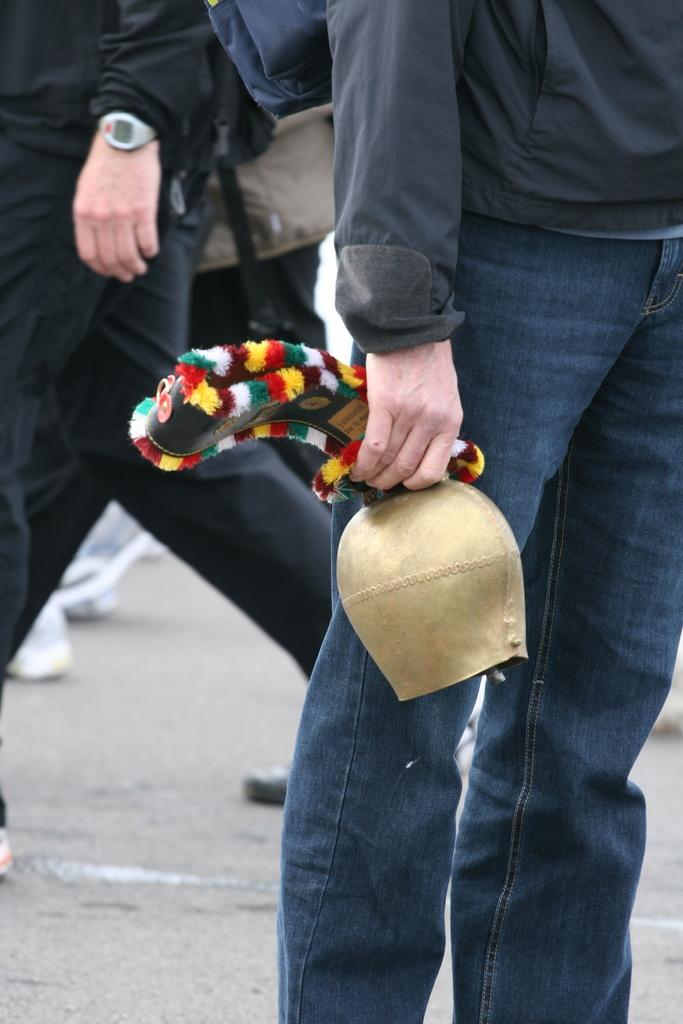What is the person in the image doing? The person is standing and holding an object in the image. Can you describe the second person in the image? The second person is on the left side of the image and is on a pathway. What type of basket is the robin carrying in the image? There is no robin or basket present in the image. 